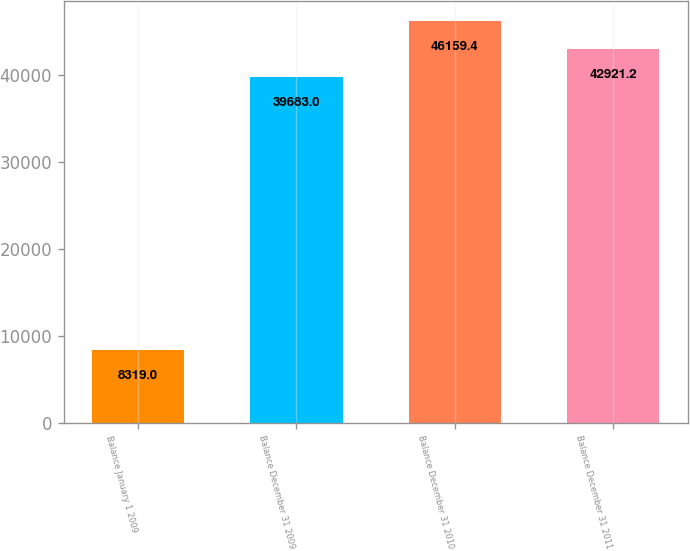Convert chart to OTSL. <chart><loc_0><loc_0><loc_500><loc_500><bar_chart><fcel>Balance January 1 2009<fcel>Balance December 31 2009<fcel>Balance December 31 2010<fcel>Balance December 31 2011<nl><fcel>8319<fcel>39683<fcel>46159.4<fcel>42921.2<nl></chart> 